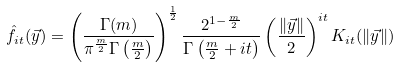Convert formula to latex. <formula><loc_0><loc_0><loc_500><loc_500>\hat { f } _ { i t } ( \vec { y } ) = \left ( \frac { \Gamma ( m ) } { \pi ^ { \frac { m } { 2 } } \Gamma \left ( \frac { m } { 2 } \right ) } \right ) ^ { \frac { 1 } { 2 } } \frac { 2 ^ { 1 - \frac { m } { 2 } } } { \Gamma \left ( \frac { m } { 2 } + i t \right ) } \left ( \frac { \| \vec { y } \| } { 2 } \right ) ^ { i t } K _ { i t } ( \| \vec { y } \| )</formula> 